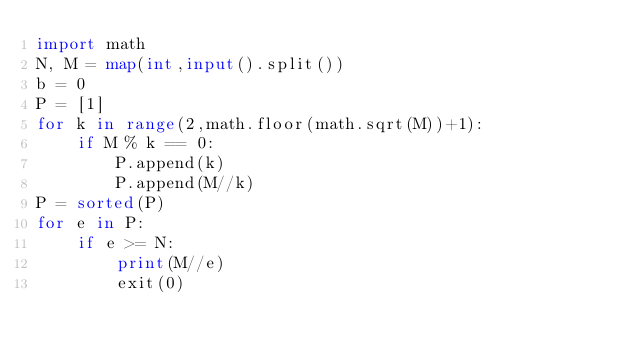<code> <loc_0><loc_0><loc_500><loc_500><_Python_>import math
N, M = map(int,input().split())
b = 0
P = [1]
for k in range(2,math.floor(math.sqrt(M))+1):
    if M % k == 0:
        P.append(k)
        P.append(M//k)
P = sorted(P)
for e in P:
    if e >= N:
        print(M//e)
        exit(0)
</code> 